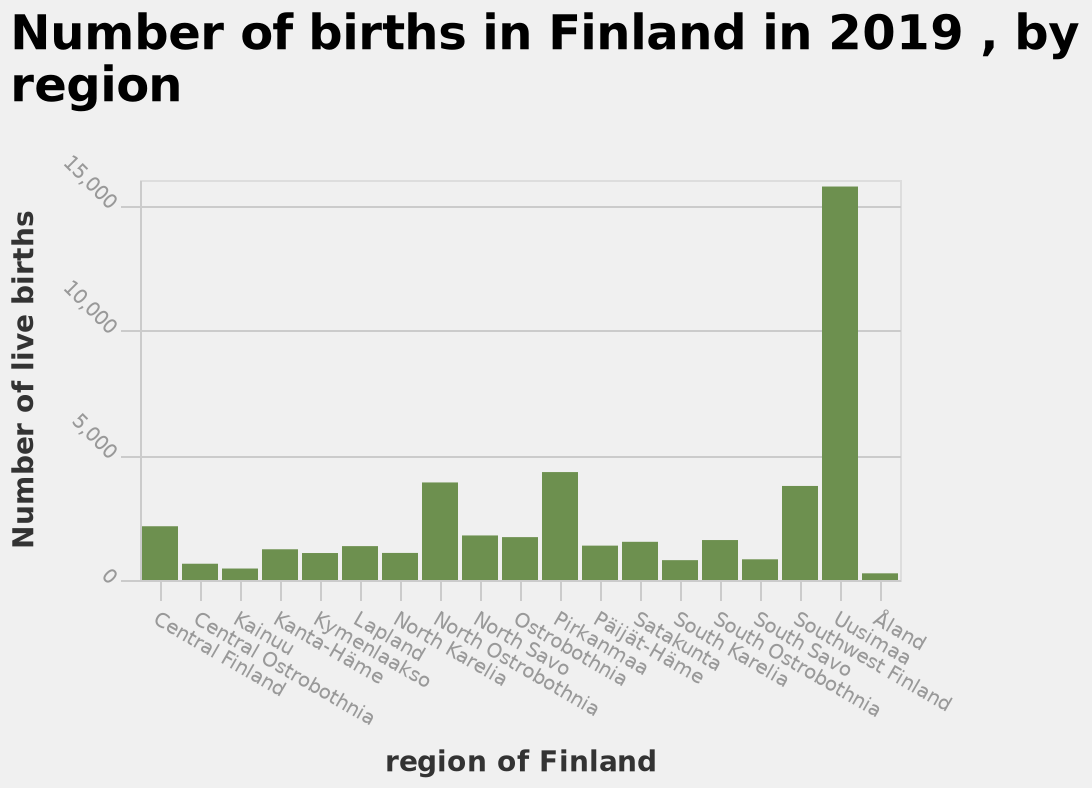<image>
What is the maximum number of live births shown on the y-axis of the bar diagram? The maximum number of live births shown on the y-axis is 15,000. 